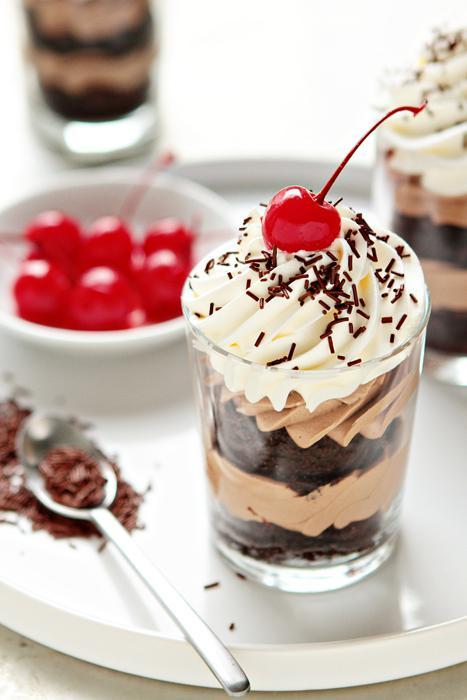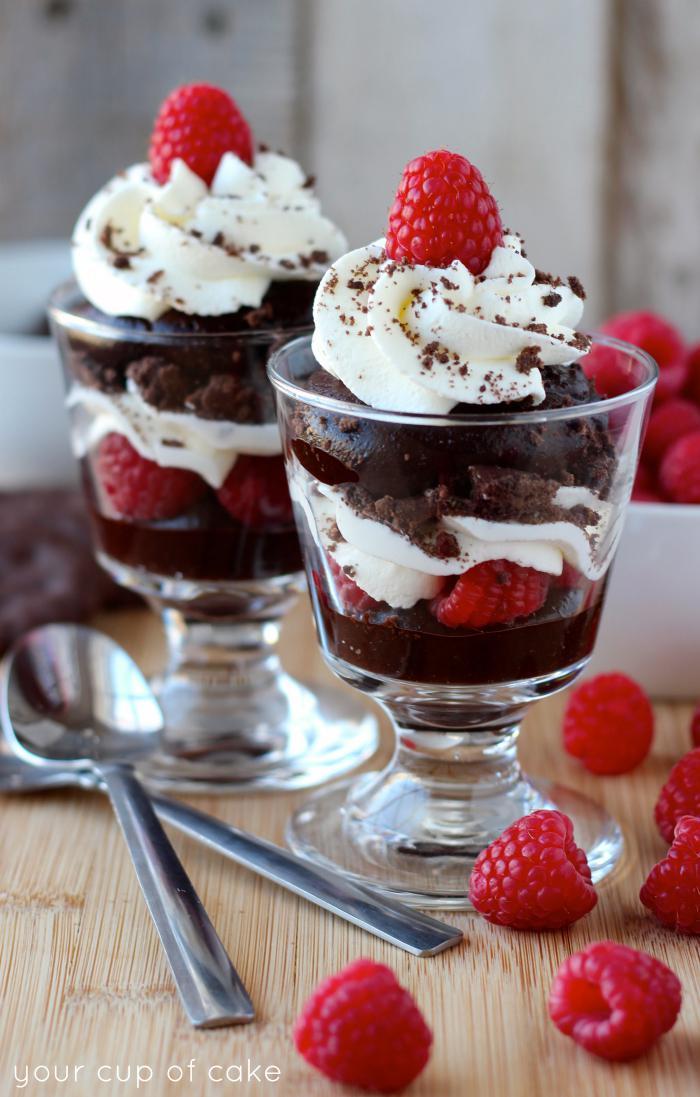The first image is the image on the left, the second image is the image on the right. Analyze the images presented: Is the assertion "there are roses on the table next to desserts with chocolate drizzled on top" valid? Answer yes or no. No. The first image is the image on the left, the second image is the image on the right. Assess this claim about the two images: "6 desserts feature a bread/cake like filling.". Correct or not? Answer yes or no. No. 